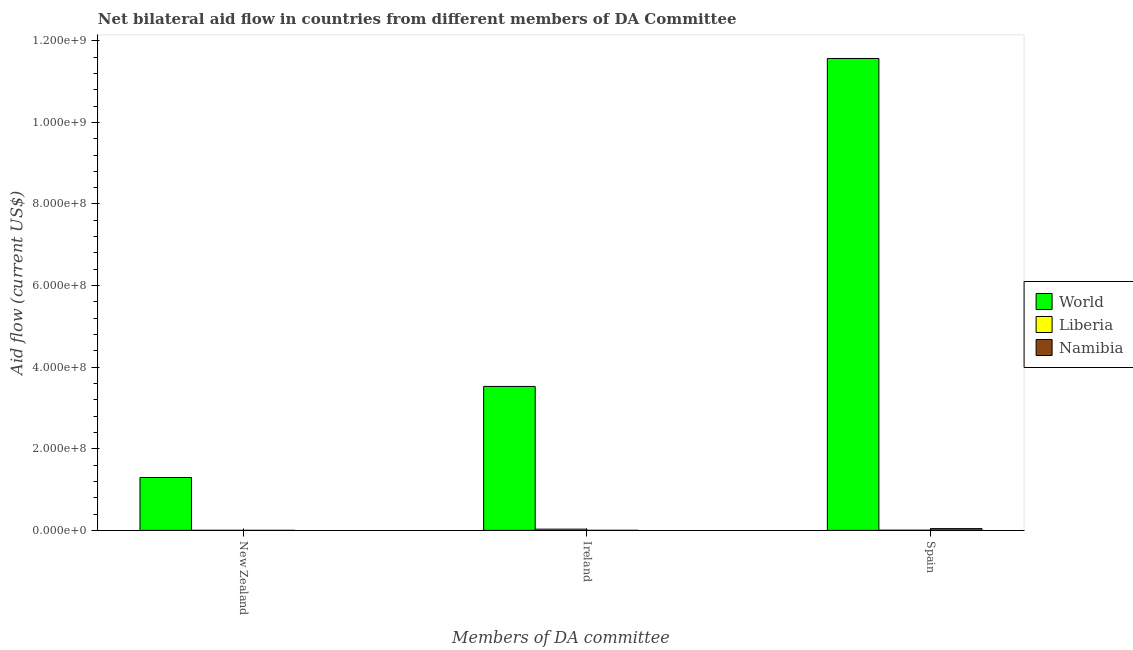Are the number of bars per tick equal to the number of legend labels?
Provide a short and direct response. Yes. Are the number of bars on each tick of the X-axis equal?
Your answer should be very brief. Yes. How many bars are there on the 2nd tick from the left?
Make the answer very short. 3. How many bars are there on the 1st tick from the right?
Provide a short and direct response. 3. What is the label of the 2nd group of bars from the left?
Provide a short and direct response. Ireland. What is the amount of aid provided by ireland in Namibia?
Provide a succinct answer. 1.60e+05. Across all countries, what is the maximum amount of aid provided by spain?
Your answer should be very brief. 1.16e+09. Across all countries, what is the minimum amount of aid provided by new zealand?
Offer a very short reply. 9.00e+04. In which country was the amount of aid provided by spain maximum?
Make the answer very short. World. In which country was the amount of aid provided by ireland minimum?
Provide a succinct answer. Namibia. What is the total amount of aid provided by spain in the graph?
Make the answer very short. 1.16e+09. What is the difference between the amount of aid provided by ireland in World and that in Liberia?
Your response must be concise. 3.50e+08. What is the difference between the amount of aid provided by spain in World and the amount of aid provided by ireland in Namibia?
Your answer should be compact. 1.16e+09. What is the average amount of aid provided by spain per country?
Offer a very short reply. 3.87e+08. What is the difference between the amount of aid provided by spain and amount of aid provided by ireland in Namibia?
Your answer should be very brief. 4.19e+06. What is the ratio of the amount of aid provided by ireland in Liberia to that in Namibia?
Give a very brief answer. 19. Is the difference between the amount of aid provided by new zealand in Namibia and Liberia greater than the difference between the amount of aid provided by spain in Namibia and Liberia?
Provide a succinct answer. No. What is the difference between the highest and the second highest amount of aid provided by spain?
Your answer should be very brief. 1.15e+09. What is the difference between the highest and the lowest amount of aid provided by new zealand?
Provide a short and direct response. 1.30e+08. In how many countries, is the amount of aid provided by ireland greater than the average amount of aid provided by ireland taken over all countries?
Offer a terse response. 1. Is the sum of the amount of aid provided by ireland in Namibia and Liberia greater than the maximum amount of aid provided by new zealand across all countries?
Keep it short and to the point. No. What does the 1st bar from the left in Ireland represents?
Offer a very short reply. World. What does the 3rd bar from the right in Ireland represents?
Offer a very short reply. World. How many bars are there?
Your response must be concise. 9. How many countries are there in the graph?
Keep it short and to the point. 3. Does the graph contain any zero values?
Offer a very short reply. No. Where does the legend appear in the graph?
Your answer should be compact. Center right. How many legend labels are there?
Make the answer very short. 3. What is the title of the graph?
Ensure brevity in your answer.  Net bilateral aid flow in countries from different members of DA Committee. What is the label or title of the X-axis?
Your answer should be compact. Members of DA committee. What is the label or title of the Y-axis?
Your answer should be compact. Aid flow (current US$). What is the Aid flow (current US$) in World in New Zealand?
Your answer should be compact. 1.30e+08. What is the Aid flow (current US$) in Namibia in New Zealand?
Make the answer very short. 9.00e+04. What is the Aid flow (current US$) of World in Ireland?
Make the answer very short. 3.53e+08. What is the Aid flow (current US$) of Liberia in Ireland?
Provide a short and direct response. 3.04e+06. What is the Aid flow (current US$) of World in Spain?
Provide a short and direct response. 1.16e+09. What is the Aid flow (current US$) in Liberia in Spain?
Provide a short and direct response. 4.60e+05. What is the Aid flow (current US$) in Namibia in Spain?
Offer a terse response. 4.35e+06. Across all Members of DA committee, what is the maximum Aid flow (current US$) in World?
Your answer should be compact. 1.16e+09. Across all Members of DA committee, what is the maximum Aid flow (current US$) in Liberia?
Offer a very short reply. 3.04e+06. Across all Members of DA committee, what is the maximum Aid flow (current US$) of Namibia?
Give a very brief answer. 4.35e+06. Across all Members of DA committee, what is the minimum Aid flow (current US$) of World?
Provide a succinct answer. 1.30e+08. Across all Members of DA committee, what is the minimum Aid flow (current US$) in Namibia?
Keep it short and to the point. 9.00e+04. What is the total Aid flow (current US$) in World in the graph?
Offer a very short reply. 1.64e+09. What is the total Aid flow (current US$) in Liberia in the graph?
Your answer should be very brief. 3.68e+06. What is the total Aid flow (current US$) in Namibia in the graph?
Keep it short and to the point. 4.60e+06. What is the difference between the Aid flow (current US$) in World in New Zealand and that in Ireland?
Provide a short and direct response. -2.23e+08. What is the difference between the Aid flow (current US$) in Liberia in New Zealand and that in Ireland?
Offer a very short reply. -2.86e+06. What is the difference between the Aid flow (current US$) of World in New Zealand and that in Spain?
Make the answer very short. -1.03e+09. What is the difference between the Aid flow (current US$) of Liberia in New Zealand and that in Spain?
Give a very brief answer. -2.80e+05. What is the difference between the Aid flow (current US$) of Namibia in New Zealand and that in Spain?
Offer a terse response. -4.26e+06. What is the difference between the Aid flow (current US$) in World in Ireland and that in Spain?
Give a very brief answer. -8.04e+08. What is the difference between the Aid flow (current US$) in Liberia in Ireland and that in Spain?
Your response must be concise. 2.58e+06. What is the difference between the Aid flow (current US$) in Namibia in Ireland and that in Spain?
Your answer should be very brief. -4.19e+06. What is the difference between the Aid flow (current US$) in World in New Zealand and the Aid flow (current US$) in Liberia in Ireland?
Give a very brief answer. 1.27e+08. What is the difference between the Aid flow (current US$) of World in New Zealand and the Aid flow (current US$) of Namibia in Ireland?
Offer a terse response. 1.29e+08. What is the difference between the Aid flow (current US$) of Liberia in New Zealand and the Aid flow (current US$) of Namibia in Ireland?
Give a very brief answer. 2.00e+04. What is the difference between the Aid flow (current US$) in World in New Zealand and the Aid flow (current US$) in Liberia in Spain?
Provide a succinct answer. 1.29e+08. What is the difference between the Aid flow (current US$) of World in New Zealand and the Aid flow (current US$) of Namibia in Spain?
Make the answer very short. 1.25e+08. What is the difference between the Aid flow (current US$) in Liberia in New Zealand and the Aid flow (current US$) in Namibia in Spain?
Make the answer very short. -4.17e+06. What is the difference between the Aid flow (current US$) in World in Ireland and the Aid flow (current US$) in Liberia in Spain?
Your response must be concise. 3.52e+08. What is the difference between the Aid flow (current US$) in World in Ireland and the Aid flow (current US$) in Namibia in Spain?
Give a very brief answer. 3.49e+08. What is the difference between the Aid flow (current US$) in Liberia in Ireland and the Aid flow (current US$) in Namibia in Spain?
Offer a very short reply. -1.31e+06. What is the average Aid flow (current US$) of World per Members of DA committee?
Make the answer very short. 5.46e+08. What is the average Aid flow (current US$) in Liberia per Members of DA committee?
Make the answer very short. 1.23e+06. What is the average Aid flow (current US$) of Namibia per Members of DA committee?
Your answer should be compact. 1.53e+06. What is the difference between the Aid flow (current US$) of World and Aid flow (current US$) of Liberia in New Zealand?
Keep it short and to the point. 1.29e+08. What is the difference between the Aid flow (current US$) in World and Aid flow (current US$) in Namibia in New Zealand?
Offer a terse response. 1.30e+08. What is the difference between the Aid flow (current US$) of World and Aid flow (current US$) of Liberia in Ireland?
Your answer should be very brief. 3.50e+08. What is the difference between the Aid flow (current US$) of World and Aid flow (current US$) of Namibia in Ireland?
Provide a short and direct response. 3.53e+08. What is the difference between the Aid flow (current US$) in Liberia and Aid flow (current US$) in Namibia in Ireland?
Provide a short and direct response. 2.88e+06. What is the difference between the Aid flow (current US$) in World and Aid flow (current US$) in Liberia in Spain?
Your answer should be compact. 1.16e+09. What is the difference between the Aid flow (current US$) of World and Aid flow (current US$) of Namibia in Spain?
Make the answer very short. 1.15e+09. What is the difference between the Aid flow (current US$) in Liberia and Aid flow (current US$) in Namibia in Spain?
Offer a very short reply. -3.89e+06. What is the ratio of the Aid flow (current US$) of World in New Zealand to that in Ireland?
Offer a very short reply. 0.37. What is the ratio of the Aid flow (current US$) of Liberia in New Zealand to that in Ireland?
Your response must be concise. 0.06. What is the ratio of the Aid flow (current US$) in Namibia in New Zealand to that in Ireland?
Give a very brief answer. 0.56. What is the ratio of the Aid flow (current US$) of World in New Zealand to that in Spain?
Your answer should be very brief. 0.11. What is the ratio of the Aid flow (current US$) of Liberia in New Zealand to that in Spain?
Provide a short and direct response. 0.39. What is the ratio of the Aid flow (current US$) of Namibia in New Zealand to that in Spain?
Give a very brief answer. 0.02. What is the ratio of the Aid flow (current US$) in World in Ireland to that in Spain?
Keep it short and to the point. 0.31. What is the ratio of the Aid flow (current US$) in Liberia in Ireland to that in Spain?
Your answer should be very brief. 6.61. What is the ratio of the Aid flow (current US$) in Namibia in Ireland to that in Spain?
Provide a short and direct response. 0.04. What is the difference between the highest and the second highest Aid flow (current US$) of World?
Provide a succinct answer. 8.04e+08. What is the difference between the highest and the second highest Aid flow (current US$) in Liberia?
Offer a very short reply. 2.58e+06. What is the difference between the highest and the second highest Aid flow (current US$) in Namibia?
Ensure brevity in your answer.  4.19e+06. What is the difference between the highest and the lowest Aid flow (current US$) in World?
Provide a short and direct response. 1.03e+09. What is the difference between the highest and the lowest Aid flow (current US$) in Liberia?
Make the answer very short. 2.86e+06. What is the difference between the highest and the lowest Aid flow (current US$) of Namibia?
Offer a terse response. 4.26e+06. 